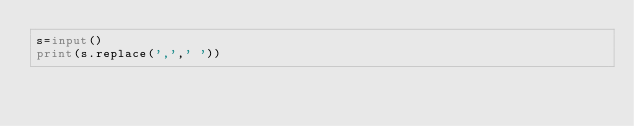Convert code to text. <code><loc_0><loc_0><loc_500><loc_500><_Python_>s=input()
print(s.replace(',',' '))
</code> 